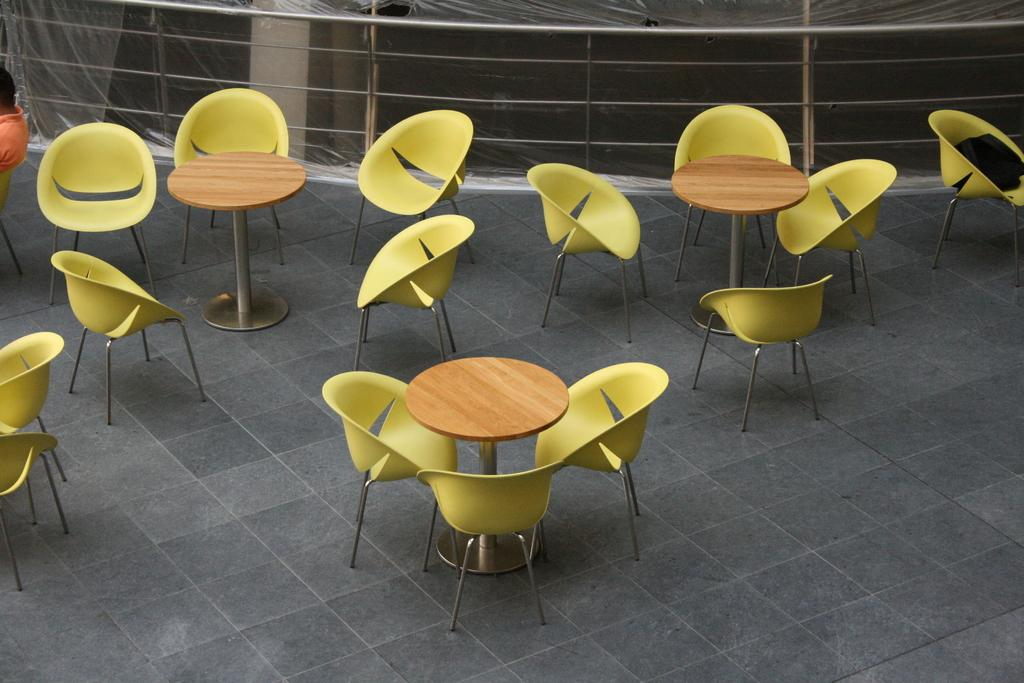What type of chairs are in the image? The chairs in the image are round-shaped and yellow. What is the shape of the tables in the image? The tables in the image are also round-shaped. What can be seen in the background of the image? There is a railing and a pillar in the background of the image. What type of belief is represented by the jar in the image? There is no jar present in the image, so it is not possible to determine any beliefs represented by it. 